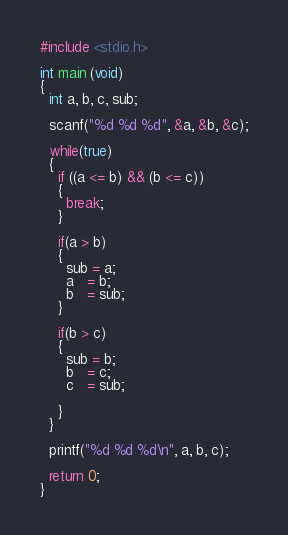<code> <loc_0><loc_0><loc_500><loc_500><_C_>#include <stdio.h>

int main (void)
{
  int a, b, c, sub;

  scanf("%d %d %d", &a, &b, &c);
  
  while(true)
  {
    if ((a <= b) && (b <= c))
    {
      break;
    }

    if(a > b)
    {
      sub = a;
      a   = b;
      b   = sub;
    }

    if(b > c)
    {
      sub = b;
      b   = c;
      c   = sub;

    }
  }

  printf("%d %d %d\n", a, b, c);

  return 0;
}</code> 